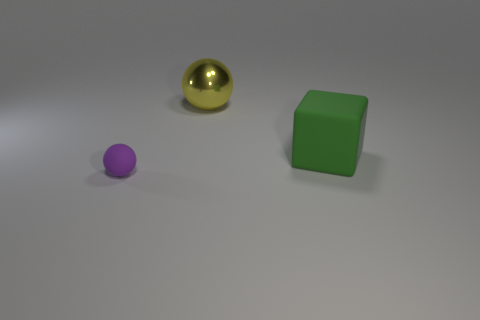Add 1 yellow metallic objects. How many objects exist? 4 Subtract all cubes. How many objects are left? 2 Add 3 big yellow shiny things. How many big yellow shiny things are left? 4 Add 1 small purple balls. How many small purple balls exist? 2 Subtract 0 green cylinders. How many objects are left? 3 Subtract all yellow balls. Subtract all purple blocks. How many balls are left? 1 Subtract all small purple matte balls. Subtract all large yellow spheres. How many objects are left? 1 